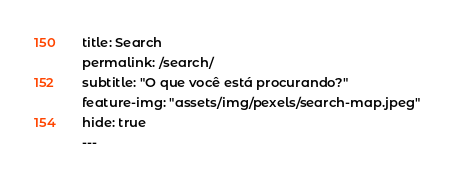<code> <loc_0><loc_0><loc_500><loc_500><_HTML_>title: Search
permalink: /search/
subtitle: "O que você está procurando?"
feature-img: "assets/img/pexels/search-map.jpeg"
hide: true
---</code> 